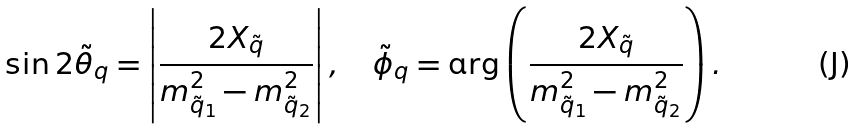Convert formula to latex. <formula><loc_0><loc_0><loc_500><loc_500>\sin 2 \tilde { \theta } _ { q } = \left | \frac { 2 X _ { \tilde { q } } } { m _ { \tilde { q } _ { 1 } } ^ { 2 } - m _ { \tilde { q } _ { 2 } } ^ { 2 } } \right | , \quad \tilde { \phi } _ { q } = \arg \left ( \frac { 2 X _ { \tilde { q } } } { m _ { \tilde { q } _ { 1 } } ^ { 2 } - m _ { \tilde { q } _ { 2 } } ^ { 2 } } \right ) .</formula> 